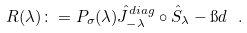Convert formula to latex. <formula><loc_0><loc_0><loc_500><loc_500>R ( \lambda ) \colon = P _ { \sigma } ( \lambda ) \hat { J } ^ { d i a g } _ { - \lambda } \circ \hat { S } _ { \lambda } - \i d \ .</formula> 